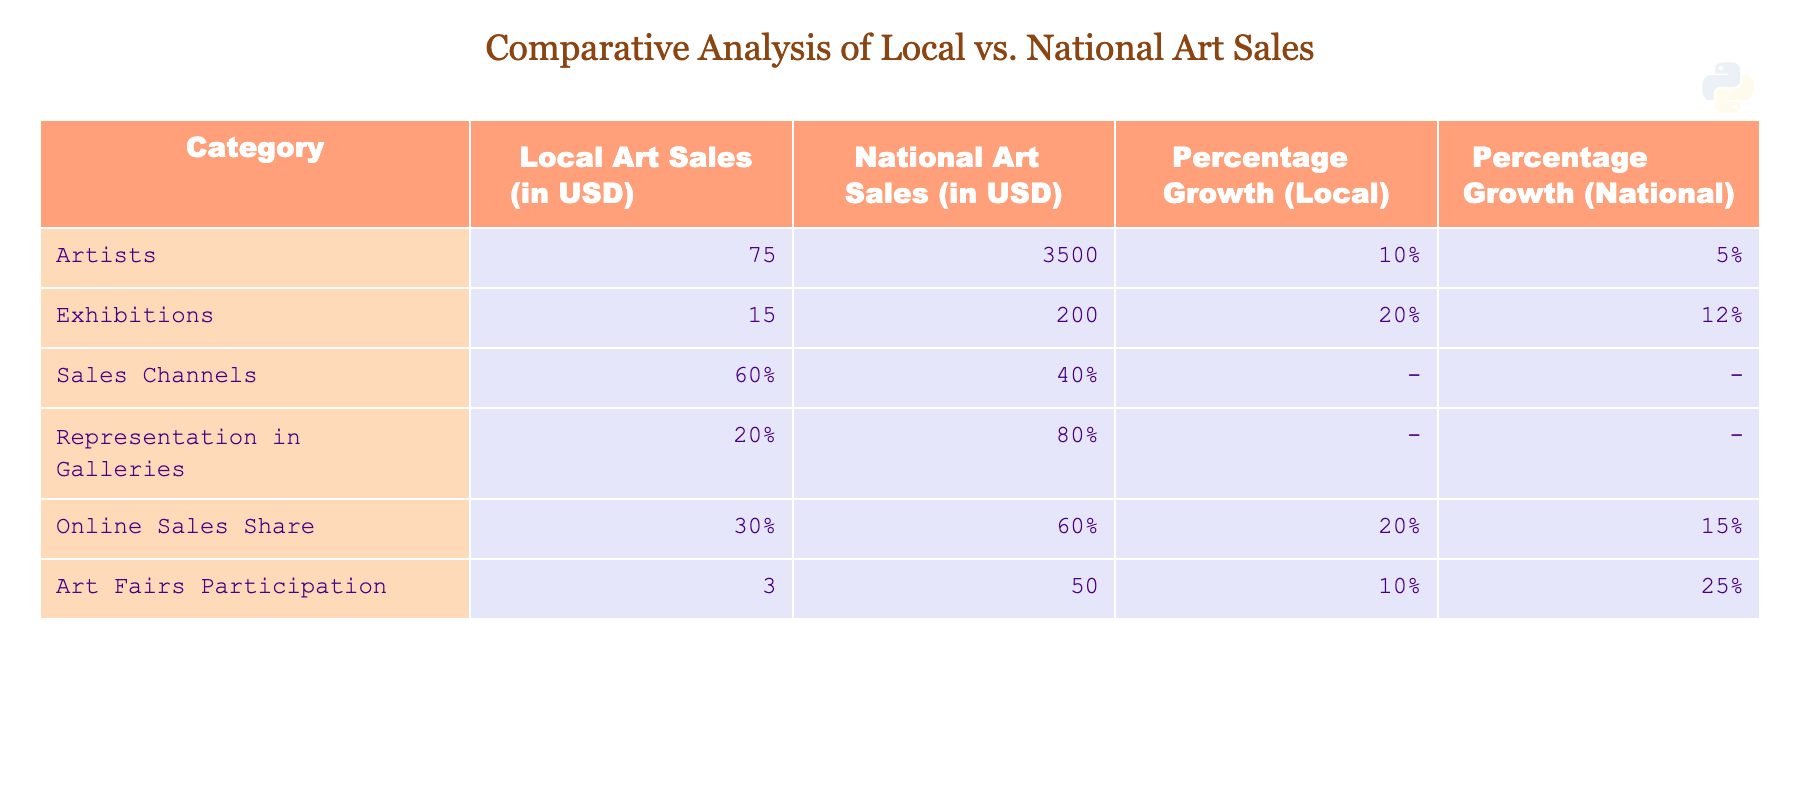What are the local art sales in USD? The table shows that the local art sales are 75 USD.
Answer: 75 USD What percentage growth did local exhibitions experience? According to the table, local exhibitions experienced a percentage growth of 20%.
Answer: 20% Which sales channel has a higher percentage: local or national? The table indicates that local sales channels stand at 60%, while national sales channels are at 40%, so local sales channels are higher.
Answer: Yes, local sales channels are higher What is the total amount of local art sales from artists and exhibitions combined? To find the total, we add the local art sales for artists (75 USD) and exhibitions (15 USD), which equals 75 + 15 = 90 USD.
Answer: 90 USD Did online sales share grow more in local art compared to national art? The table shows that local online sales share grew by 20%, whereas national sales grew by 15%, therefore local growth is higher.
Answer: Yes, local online sales share grew more What is the ratio of representations in galleries between local and national art? Local representation is at 20% and national is at 80%. The ratio is 20:80, which simplifies to 1:4.
Answer: 1:4 What is the average percentage growth across local and national art sales? The average growth for local can be calculated as (10% + 20% + 20% + 30% + 10%) / 5 = 18%. For national, it is (5% + 12% + 15% + 25%) / 4 = 14.25%. Therefore, the averages are approximately 18% for local and 14.25% for national.
Answer: Local: 18%, National: 14.25% How many more art fairs participated nationally compared to locally? The table provides that 50 art fairs participated nationwide while only 3 participated locally. The difference is 50 - 3 = 47.
Answer: 47 What is the total percentage for online sales share for both local and national art? The local online sales share is 30% and national is 60%. The total percentage is 30 + 60 = 90%.
Answer: 90% 